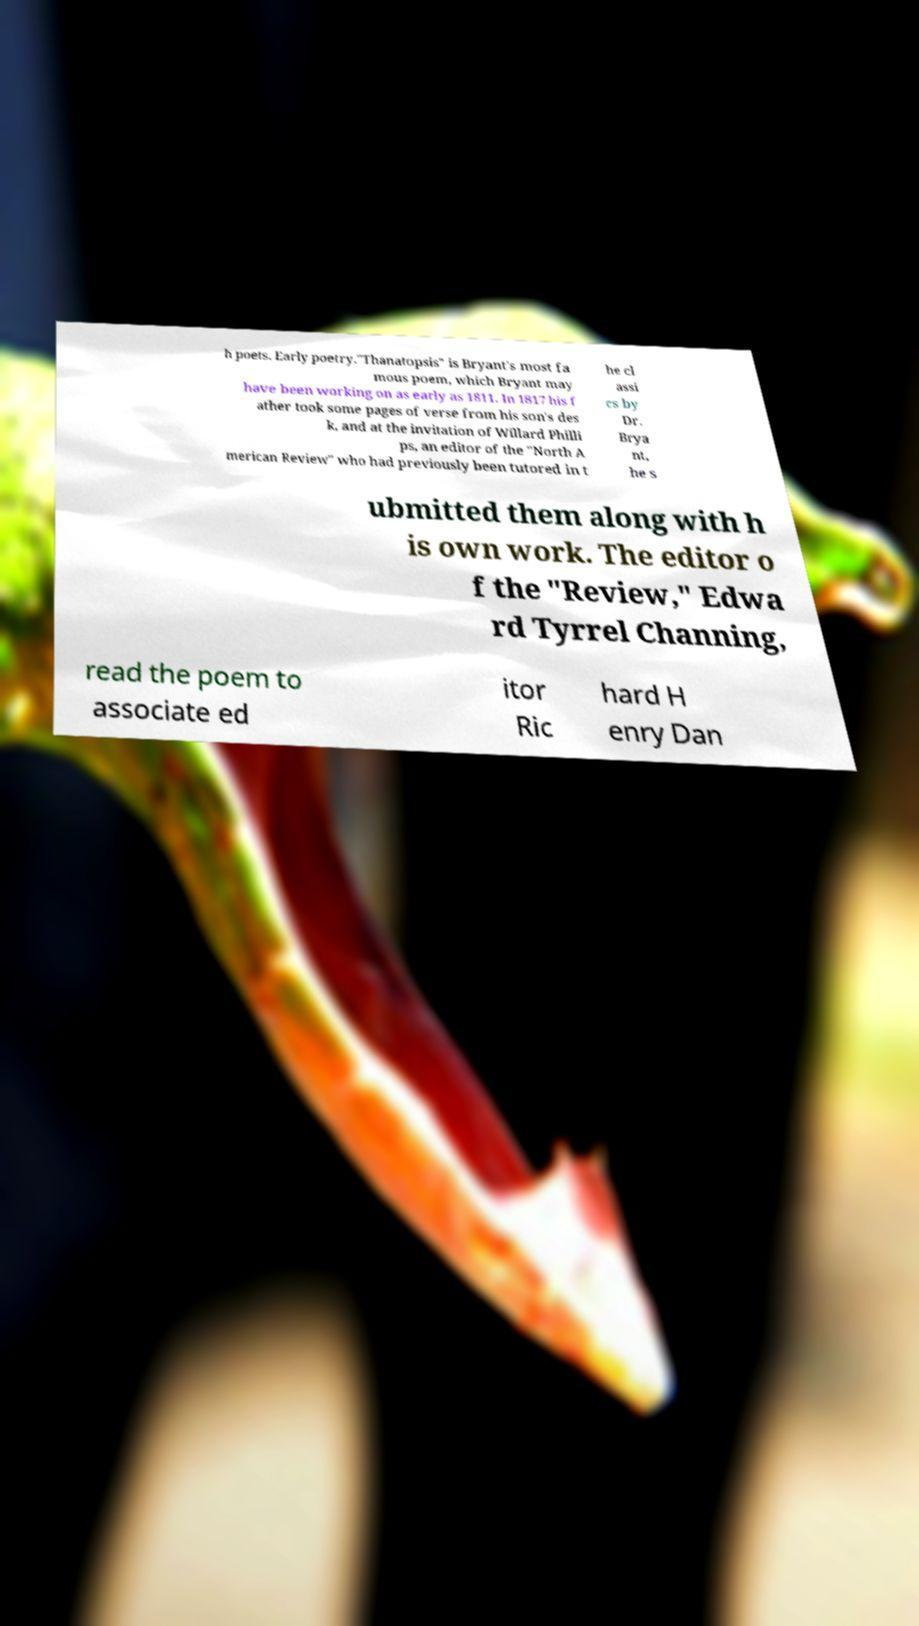For documentation purposes, I need the text within this image transcribed. Could you provide that? h poets. Early poetry."Thanatopsis" is Bryant's most fa mous poem, which Bryant may have been working on as early as 1811. In 1817 his f ather took some pages of verse from his son's des k, and at the invitation of Willard Philli ps, an editor of the "North A merican Review" who had previously been tutored in t he cl assi cs by Dr. Brya nt, he s ubmitted them along with h is own work. The editor o f the "Review," Edwa rd Tyrrel Channing, read the poem to associate ed itor Ric hard H enry Dan 